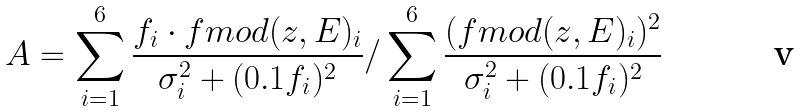Convert formula to latex. <formula><loc_0><loc_0><loc_500><loc_500>A = \sum _ { i = 1 } ^ { 6 } \frac { f _ { i } \cdot f m o d ( z , E ) _ { i } } { \sigma _ { i } ^ { 2 } + ( 0 . 1 f _ { i } ) ^ { 2 } } / \sum _ { i = 1 } ^ { 6 } \frac { ( f m o d ( z , E ) _ { i } ) ^ { 2 } } { \sigma _ { i } ^ { 2 } + ( 0 . 1 f _ { i } ) ^ { 2 } }</formula> 